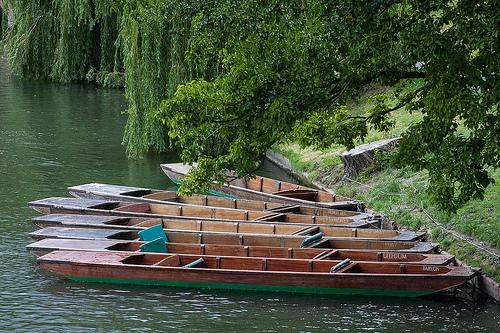Question: who is in the water?
Choices:
A. Swimmers.
B. Rescuers.
C. Surfers.
D. No one.
Answer with the letter. Answer: D Question: how many boats are there?
Choices:
A. 1.
B. 2.
C. 7.
D. 3.
Answer with the letter. Answer: C Question: where was the pic taken from?
Choices:
A. Temple.
B. Lake.
C. Cabin.
D. Sea.
Answer with the letter. Answer: D Question: when was the pic teken?
Choices:
A. At midnight.
B. At noon.
C. During the day.
D. During the morning.
Answer with the letter. Answer: C 